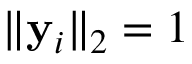Convert formula to latex. <formula><loc_0><loc_0><loc_500><loc_500>\| y _ { i } \| _ { 2 } = 1</formula> 